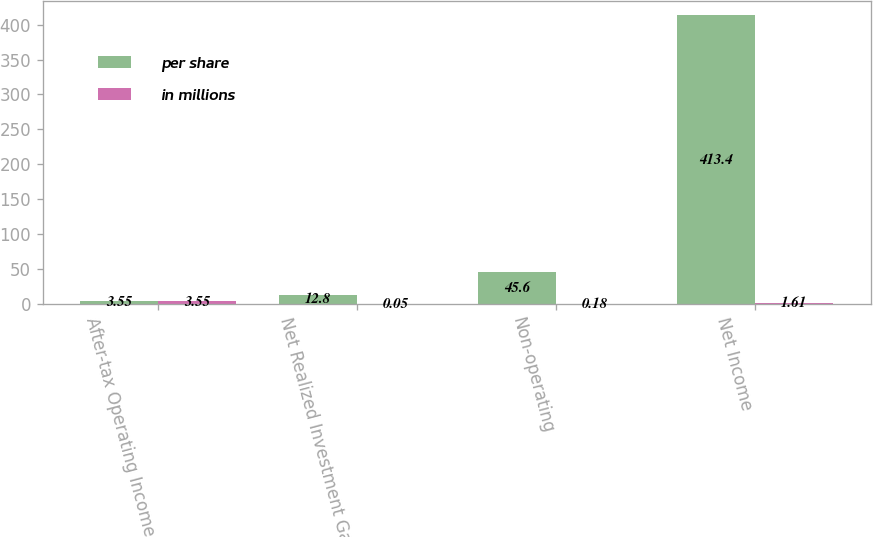Convert chart. <chart><loc_0><loc_0><loc_500><loc_500><stacked_bar_chart><ecel><fcel>After-tax Operating Income<fcel>Net Realized Investment Gain<fcel>Non-operating<fcel>Net Income<nl><fcel>per share<fcel>3.55<fcel>12.8<fcel>45.6<fcel>413.4<nl><fcel>in millions<fcel>3.55<fcel>0.05<fcel>0.18<fcel>1.61<nl></chart> 